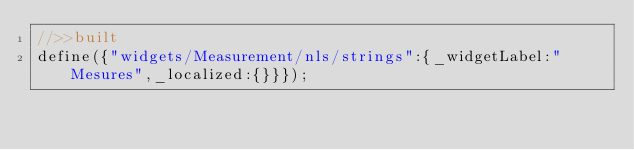Convert code to text. <code><loc_0><loc_0><loc_500><loc_500><_JavaScript_>//>>built
define({"widgets/Measurement/nls/strings":{_widgetLabel:"Mesures",_localized:{}}});</code> 